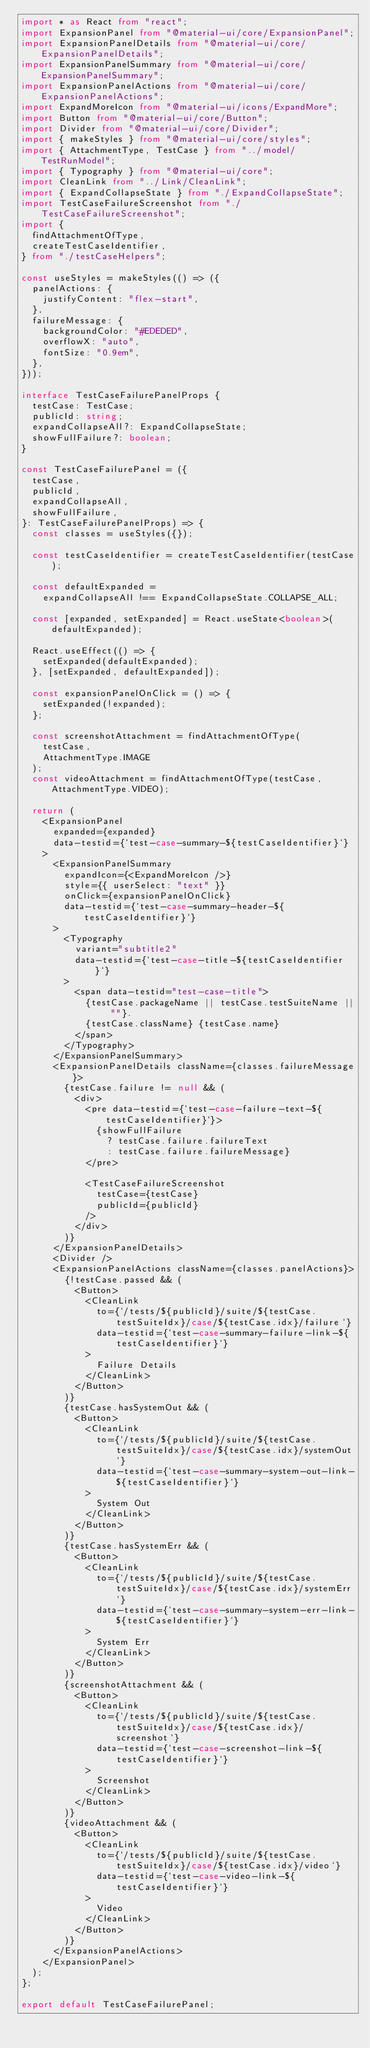<code> <loc_0><loc_0><loc_500><loc_500><_TypeScript_>import * as React from "react";
import ExpansionPanel from "@material-ui/core/ExpansionPanel";
import ExpansionPanelDetails from "@material-ui/core/ExpansionPanelDetails";
import ExpansionPanelSummary from "@material-ui/core/ExpansionPanelSummary";
import ExpansionPanelActions from "@material-ui/core/ExpansionPanelActions";
import ExpandMoreIcon from "@material-ui/icons/ExpandMore";
import Button from "@material-ui/core/Button";
import Divider from "@material-ui/core/Divider";
import { makeStyles } from "@material-ui/core/styles";
import { AttachmentType, TestCase } from "../model/TestRunModel";
import { Typography } from "@material-ui/core";
import CleanLink from "../Link/CleanLink";
import { ExpandCollapseState } from "./ExpandCollapseState";
import TestCaseFailureScreenshot from "./TestCaseFailureScreenshot";
import {
  findAttachmentOfType,
  createTestCaseIdentifier,
} from "./testCaseHelpers";

const useStyles = makeStyles(() => ({
  panelActions: {
    justifyContent: "flex-start",
  },
  failureMessage: {
    backgroundColor: "#EDEDED",
    overflowX: "auto",
    fontSize: "0.9em",
  },
}));

interface TestCaseFailurePanelProps {
  testCase: TestCase;
  publicId: string;
  expandCollapseAll?: ExpandCollapseState;
  showFullFailure?: boolean;
}

const TestCaseFailurePanel = ({
  testCase,
  publicId,
  expandCollapseAll,
  showFullFailure,
}: TestCaseFailurePanelProps) => {
  const classes = useStyles({});

  const testCaseIdentifier = createTestCaseIdentifier(testCase);

  const defaultExpanded =
    expandCollapseAll !== ExpandCollapseState.COLLAPSE_ALL;

  const [expanded, setExpanded] = React.useState<boolean>(defaultExpanded);

  React.useEffect(() => {
    setExpanded(defaultExpanded);
  }, [setExpanded, defaultExpanded]);

  const expansionPanelOnClick = () => {
    setExpanded(!expanded);
  };

  const screenshotAttachment = findAttachmentOfType(
    testCase,
    AttachmentType.IMAGE
  );
  const videoAttachment = findAttachmentOfType(testCase, AttachmentType.VIDEO);

  return (
    <ExpansionPanel
      expanded={expanded}
      data-testid={`test-case-summary-${testCaseIdentifier}`}
    >
      <ExpansionPanelSummary
        expandIcon={<ExpandMoreIcon />}
        style={{ userSelect: "text" }}
        onClick={expansionPanelOnClick}
        data-testid={`test-case-summary-header-${testCaseIdentifier}`}
      >
        <Typography
          variant="subtitle2"
          data-testid={`test-case-title-${testCaseIdentifier}`}
        >
          <span data-testid="test-case-title">
            {testCase.packageName || testCase.testSuiteName || ""}.
            {testCase.className} {testCase.name}
          </span>
        </Typography>
      </ExpansionPanelSummary>
      <ExpansionPanelDetails className={classes.failureMessage}>
        {testCase.failure != null && (
          <div>
            <pre data-testid={`test-case-failure-text-${testCaseIdentifier}`}>
              {showFullFailure
                ? testCase.failure.failureText
                : testCase.failure.failureMessage}
            </pre>

            <TestCaseFailureScreenshot
              testCase={testCase}
              publicId={publicId}
            />
          </div>
        )}
      </ExpansionPanelDetails>
      <Divider />
      <ExpansionPanelActions className={classes.panelActions}>
        {!testCase.passed && (
          <Button>
            <CleanLink
              to={`/tests/${publicId}/suite/${testCase.testSuiteIdx}/case/${testCase.idx}/failure`}
              data-testid={`test-case-summary-failure-link-${testCaseIdentifier}`}
            >
              Failure Details
            </CleanLink>
          </Button>
        )}
        {testCase.hasSystemOut && (
          <Button>
            <CleanLink
              to={`/tests/${publicId}/suite/${testCase.testSuiteIdx}/case/${testCase.idx}/systemOut`}
              data-testid={`test-case-summary-system-out-link-${testCaseIdentifier}`}
            >
              System Out
            </CleanLink>
          </Button>
        )}
        {testCase.hasSystemErr && (
          <Button>
            <CleanLink
              to={`/tests/${publicId}/suite/${testCase.testSuiteIdx}/case/${testCase.idx}/systemErr`}
              data-testid={`test-case-summary-system-err-link-${testCaseIdentifier}`}
            >
              System Err
            </CleanLink>
          </Button>
        )}
        {screenshotAttachment && (
          <Button>
            <CleanLink
              to={`/tests/${publicId}/suite/${testCase.testSuiteIdx}/case/${testCase.idx}/screenshot`}
              data-testid={`test-case-screenshot-link-${testCaseIdentifier}`}
            >
              Screenshot
            </CleanLink>
          </Button>
        )}
        {videoAttachment && (
          <Button>
            <CleanLink
              to={`/tests/${publicId}/suite/${testCase.testSuiteIdx}/case/${testCase.idx}/video`}
              data-testid={`test-case-video-link-${testCaseIdentifier}`}
            >
              Video
            </CleanLink>
          </Button>
        )}
      </ExpansionPanelActions>
    </ExpansionPanel>
  );
};

export default TestCaseFailurePanel;
</code> 